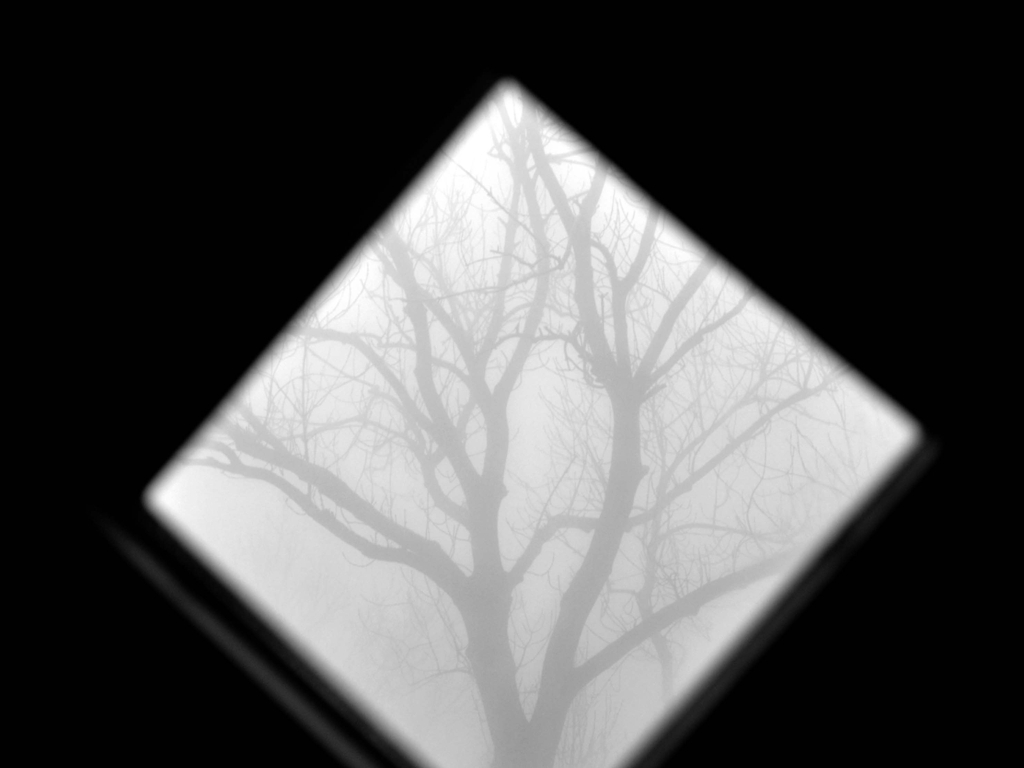What feeling does this image evoke, and could you elaborate on its possible symbolic meaning? The image, featuring tree branches sharply silhouetted against a misty, clouded backdrop, strongly evokes a feeling of solitude or perhaps melancholic introspection. Symbolically, the tree's intricate branches can be seen as a metaphor for the complexities of our thoughts or emotions—twisting and turning in unexpected ways. The fog adds a layer of mystery and ambiguity, hinting at the uncertainty inherent in our futures or the indistinct edges of our subconscious thoughts. The vantage point, looking up through a frame, may suggest a restricted or limited perspective, encouraging viewers to consider the bigger picture beyond immediate appearances. 